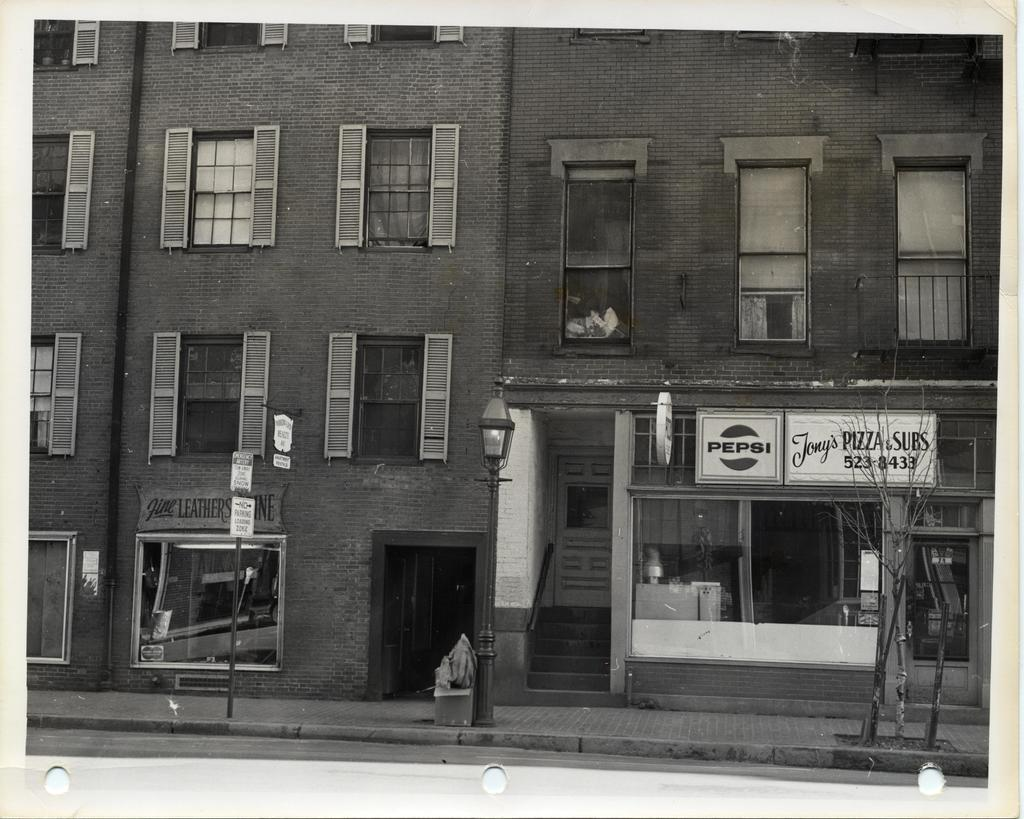What type of structure is present in the image? There is a building in the image. What can be seen illuminated in the image? There are lights visible in the image. What type of pathway is at the bottom of the image? There is a sideway at the bottom of the image. What type of transportation route is present in the image? There is a road in the image. What type of glue is being used to hold the building together in the image? There is no mention of glue or any construction materials in the image; it only shows a building, lights, a sideway, and a road. 